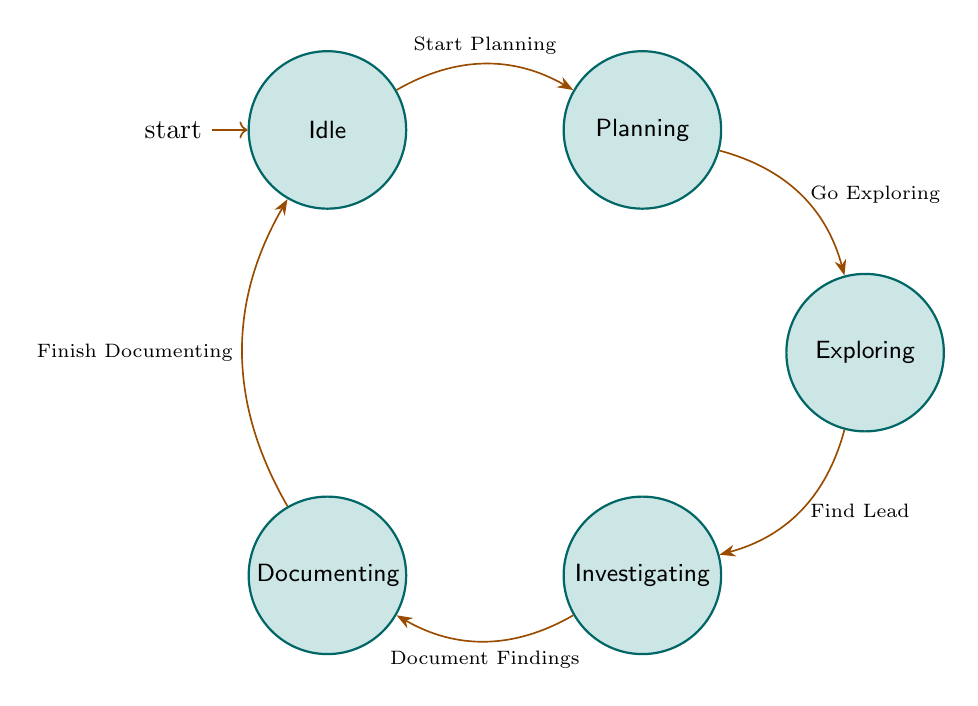What is the initial state in the diagram? The diagram indicates that the initial state is represented by an arrow pointing to the "Idle" node, showing that this is the starting point of the state machine.
Answer: Idle How many states are present in the diagram? The diagram lists five distinct nodes: Idle, Planning, Exploring, Investigating, and Documenting. Therefore, we can count these to determine that there are five states in total.
Answer: 5 What transition occurs from "Planning" to "Exploring"? The transition from "Planning" to "Exploring" is labeled "Go Exploring", indicating the action taken to move from planning to actually exploring the wilderness.
Answer: Go Exploring Which state do you go to after "Investigating"? Following the "Investigating" state, the diagram indicates a transition where one documents their findings, leading directly to the "Documenting" state.
Answer: Documenting What state follows "Documenting"? From the "Documenting" state, the diagram specifies a transition labeled "Finish Documenting", which leads back to the "Idle" state, indicating the return to the beginning after documenting their findings.
Answer: Idle If you're in the "Exploring" state, what is the next possible transition? The diagram shows that from the "Exploring" state, the available transition is labeled "Find Lead", which allows the exploration to lead into a more investigative phase based on finding potential evidence of legendary creatures.
Answer: Find Lead What is the final state reached after "Documenting"? After the "Documenting" state, the diagram indicates that the process loops back to "Idle" when the transition "Finish Documenting" is taken. This reflects a complete cycle of searching for legendary creatures.
Answer: Idle What direction do you transition from "Idle" to "Planning"? The direction of the transition from "Idle" to "Planning" is indicated by a bend in the arrow labeled "Start Planning", showing that this transition moves upward to the right towards the Planning state.
Answer: Start Planning Which state comes before "Investigating"? The state that precedes "Investigating" in the diagram is "Exploring", which is the state where one would search for signs before potentially finding a lead and advancing to investigation.
Answer: Exploring 